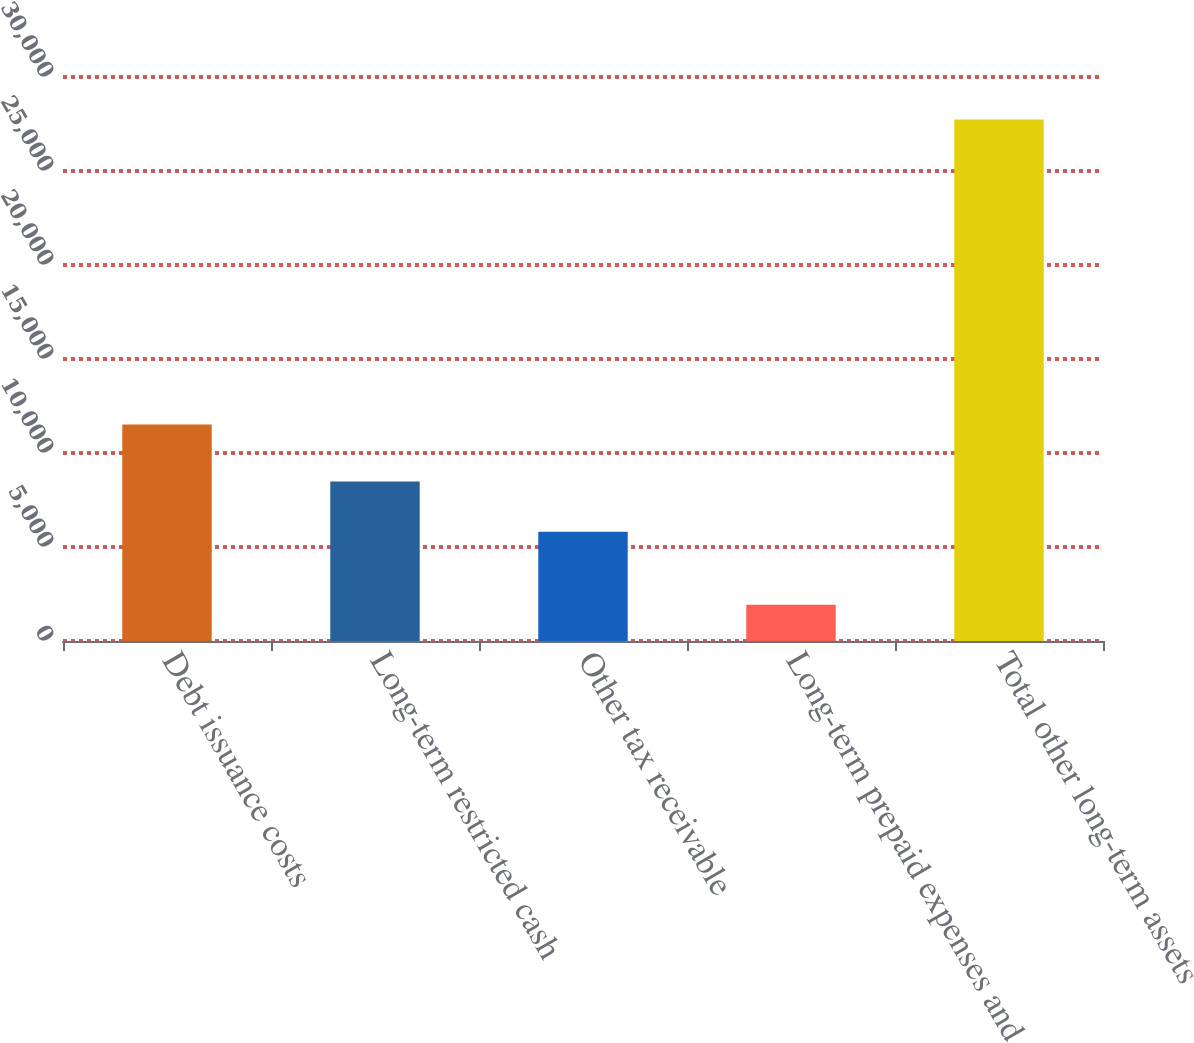<chart> <loc_0><loc_0><loc_500><loc_500><bar_chart><fcel>Debt issuance costs<fcel>Long-term restricted cash<fcel>Other tax receivable<fcel>Long-term prepaid expenses and<fcel>Total other long-term assets<nl><fcel>11521<fcel>8479<fcel>5811<fcel>1934<fcel>27745<nl></chart> 